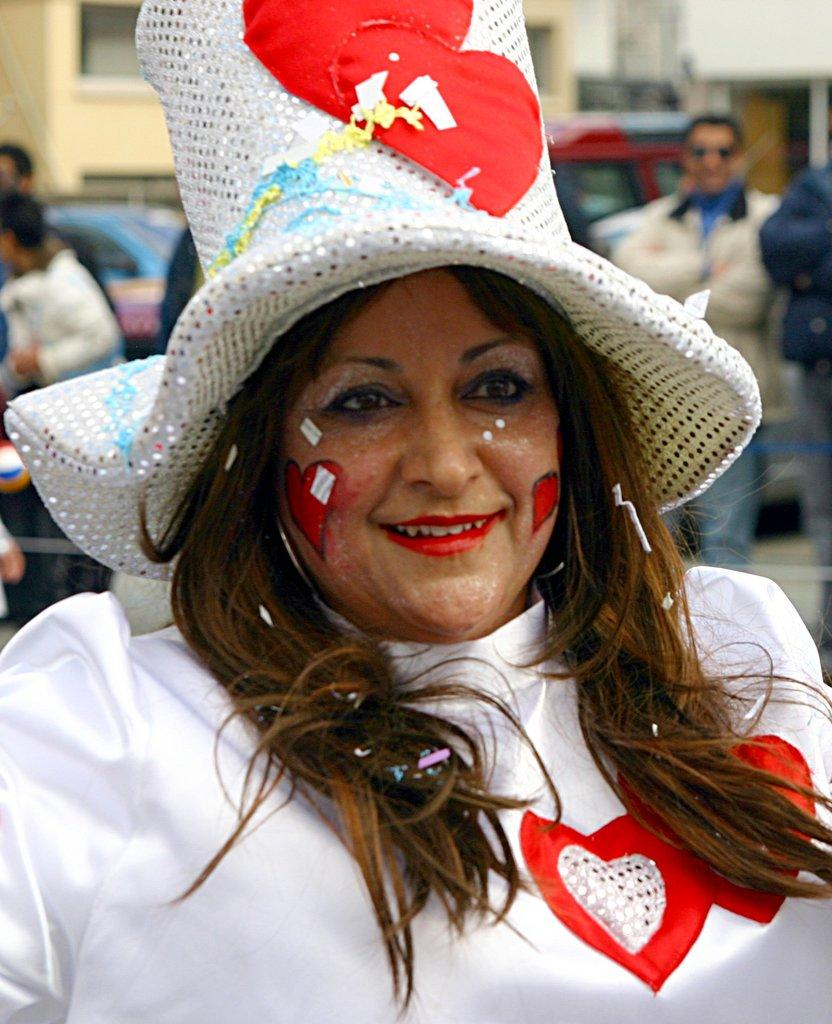Who is present in the image? There is a woman in the image. What is the woman doing in the image? The woman is smiling in the image. What is the woman wearing in the image? The woman is wearing a hat in the image. Can you describe the background of the image? The background of the image is blurry, but there is a wall and people visible. What else can be seen in the background of the image? There are also vehicles in the background of the image. What type of pear is the woman holding in the image? There is no pear present in the image. What type of plant is growing on the woman's hat in the image? There is no plant growing on the woman's hat in the image. 